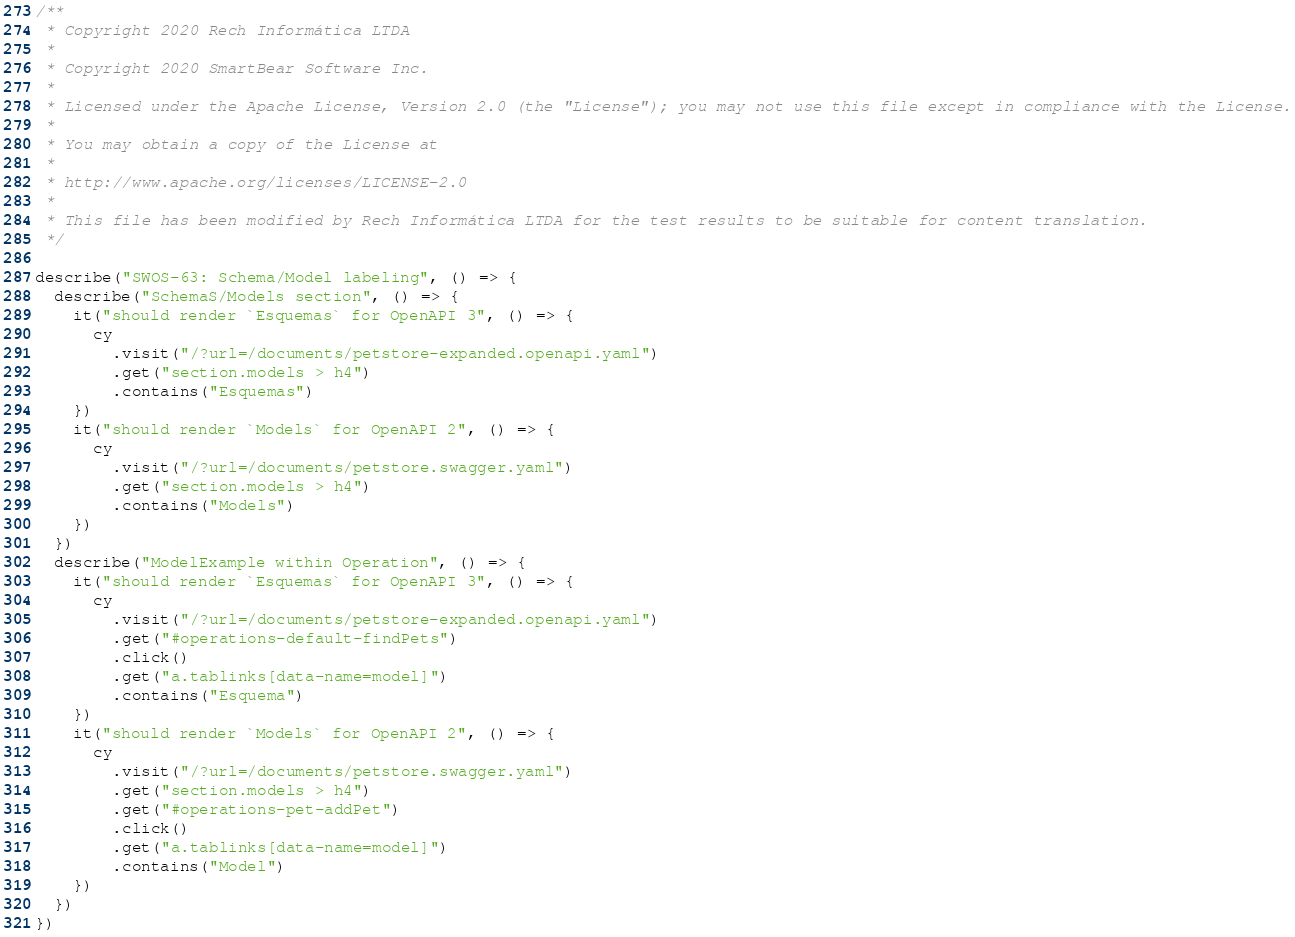Convert code to text. <code><loc_0><loc_0><loc_500><loc_500><_JavaScript_>/**
 * Copyright 2020 Rech Informática LTDA
 *
 * Copyright 2020 SmartBear Software Inc.
 *
 * Licensed under the Apache License, Version 2.0 (the "License"); you may not use this file except in compliance with the License.
 *
 * You may obtain a copy of the License at
 *
 * http://www.apache.org/licenses/LICENSE-2.0
 *
 * This file has been modified by Rech Informática LTDA for the test results to be suitable for content translation.
 */

describe("SWOS-63: Schema/Model labeling", () => {
  describe("SchemaS/Models section", () => {
    it("should render `Esquemas` for OpenAPI 3", () => {
      cy
        .visit("/?url=/documents/petstore-expanded.openapi.yaml")
        .get("section.models > h4")
        .contains("Esquemas")
    })
    it("should render `Models` for OpenAPI 2", () => {
      cy
        .visit("/?url=/documents/petstore.swagger.yaml")
        .get("section.models > h4")
        .contains("Models")
    })
  })
  describe("ModelExample within Operation", () => {
    it("should render `Esquemas` for OpenAPI 3", () => {
      cy
        .visit("/?url=/documents/petstore-expanded.openapi.yaml")
        .get("#operations-default-findPets")
        .click()
        .get("a.tablinks[data-name=model]")
        .contains("Esquema")
    })
    it("should render `Models` for OpenAPI 2", () => {
      cy
        .visit("/?url=/documents/petstore.swagger.yaml")
        .get("section.models > h4")
        .get("#operations-pet-addPet")
        .click()
        .get("a.tablinks[data-name=model]")
        .contains("Model")
    })
  })
})
</code> 